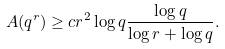<formula> <loc_0><loc_0><loc_500><loc_500>A ( q ^ { r } ) \geq c r ^ { 2 } \log q \frac { \log q } { \log r + \log q } .</formula> 